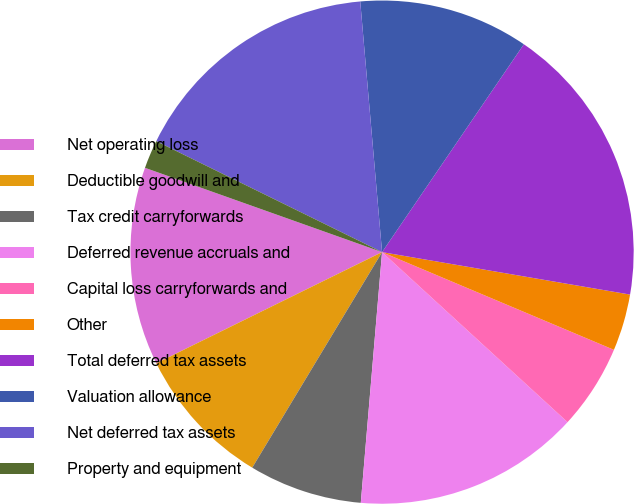<chart> <loc_0><loc_0><loc_500><loc_500><pie_chart><fcel>Net operating loss<fcel>Deductible goodwill and<fcel>Tax credit carryforwards<fcel>Deferred revenue accruals and<fcel>Capital loss carryforwards and<fcel>Other<fcel>Total deferred tax assets<fcel>Valuation allowance<fcel>Net deferred tax assets<fcel>Property and equipment<nl><fcel>12.72%<fcel>9.09%<fcel>7.28%<fcel>14.54%<fcel>5.46%<fcel>3.65%<fcel>18.17%<fcel>10.91%<fcel>16.35%<fcel>1.83%<nl></chart> 